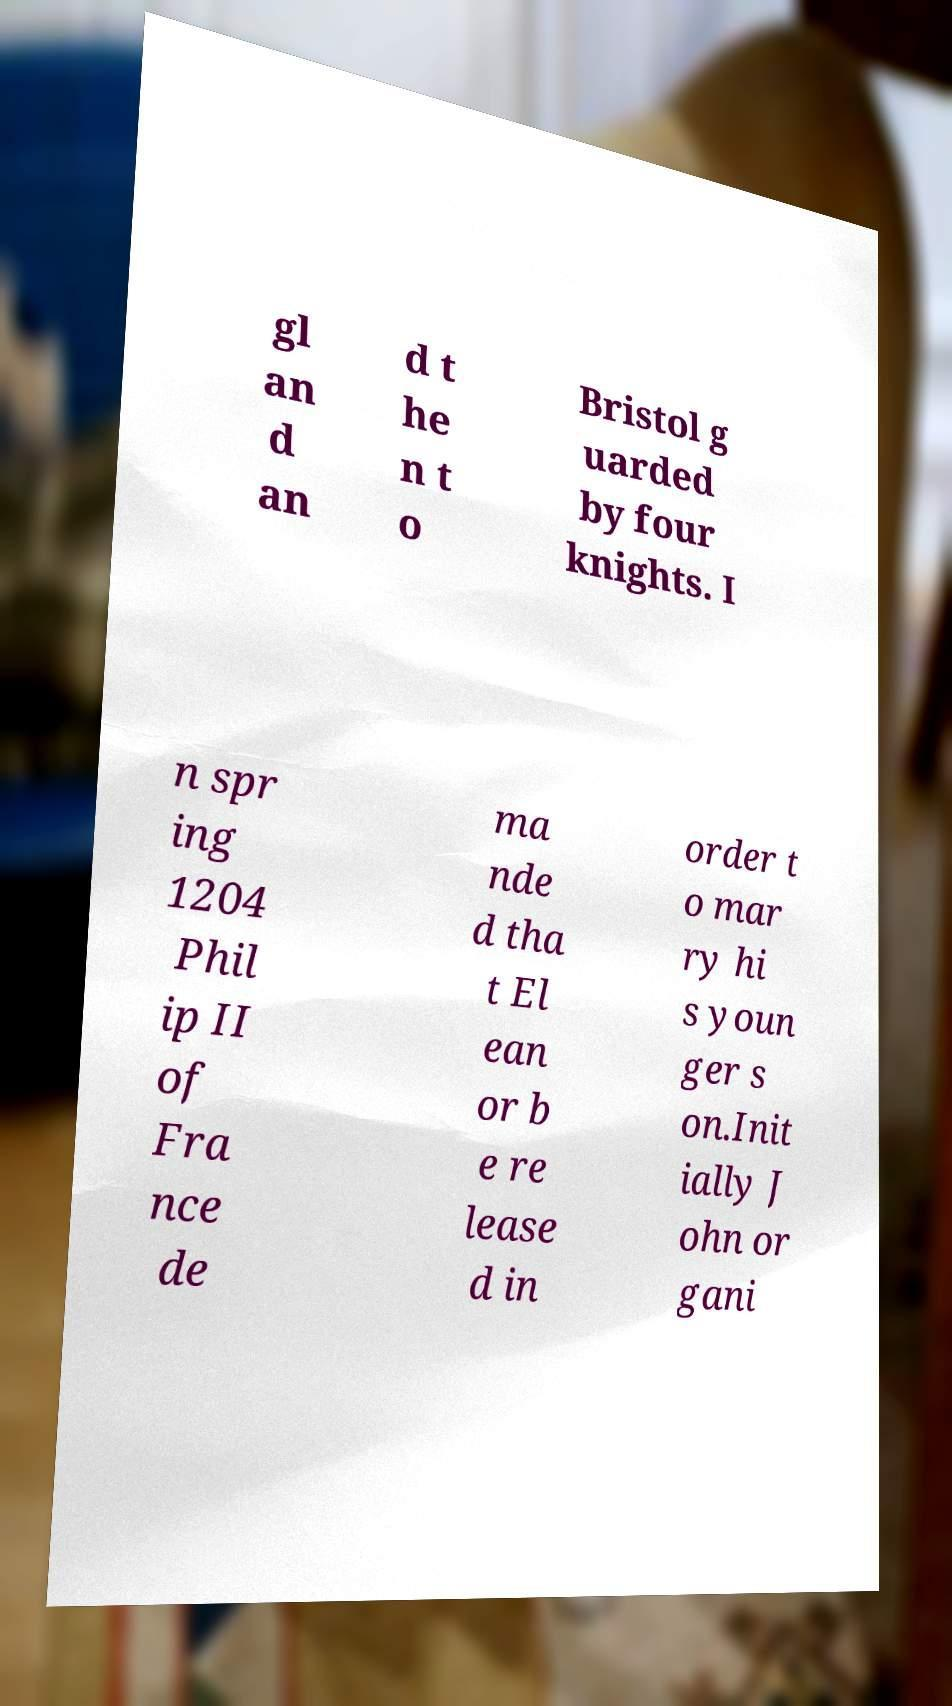What messages or text are displayed in this image? I need them in a readable, typed format. gl an d an d t he n t o Bristol g uarded by four knights. I n spr ing 1204 Phil ip II of Fra nce de ma nde d tha t El ean or b e re lease d in order t o mar ry hi s youn ger s on.Init ially J ohn or gani 